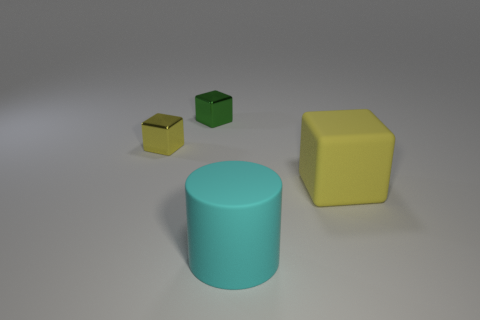Subtract all cyan cylinders. How many yellow blocks are left? 2 Add 1 large cyan rubber objects. How many objects exist? 5 Subtract all yellow shiny blocks. How many blocks are left? 2 Subtract 1 blocks. How many blocks are left? 2 Subtract all cylinders. How many objects are left? 3 Add 3 small yellow shiny blocks. How many small yellow shiny blocks are left? 4 Add 1 green cubes. How many green cubes exist? 2 Subtract 0 red cubes. How many objects are left? 4 Subtract all gray cylinders. Subtract all cyan spheres. How many cylinders are left? 1 Subtract all tiny green matte blocks. Subtract all big yellow things. How many objects are left? 3 